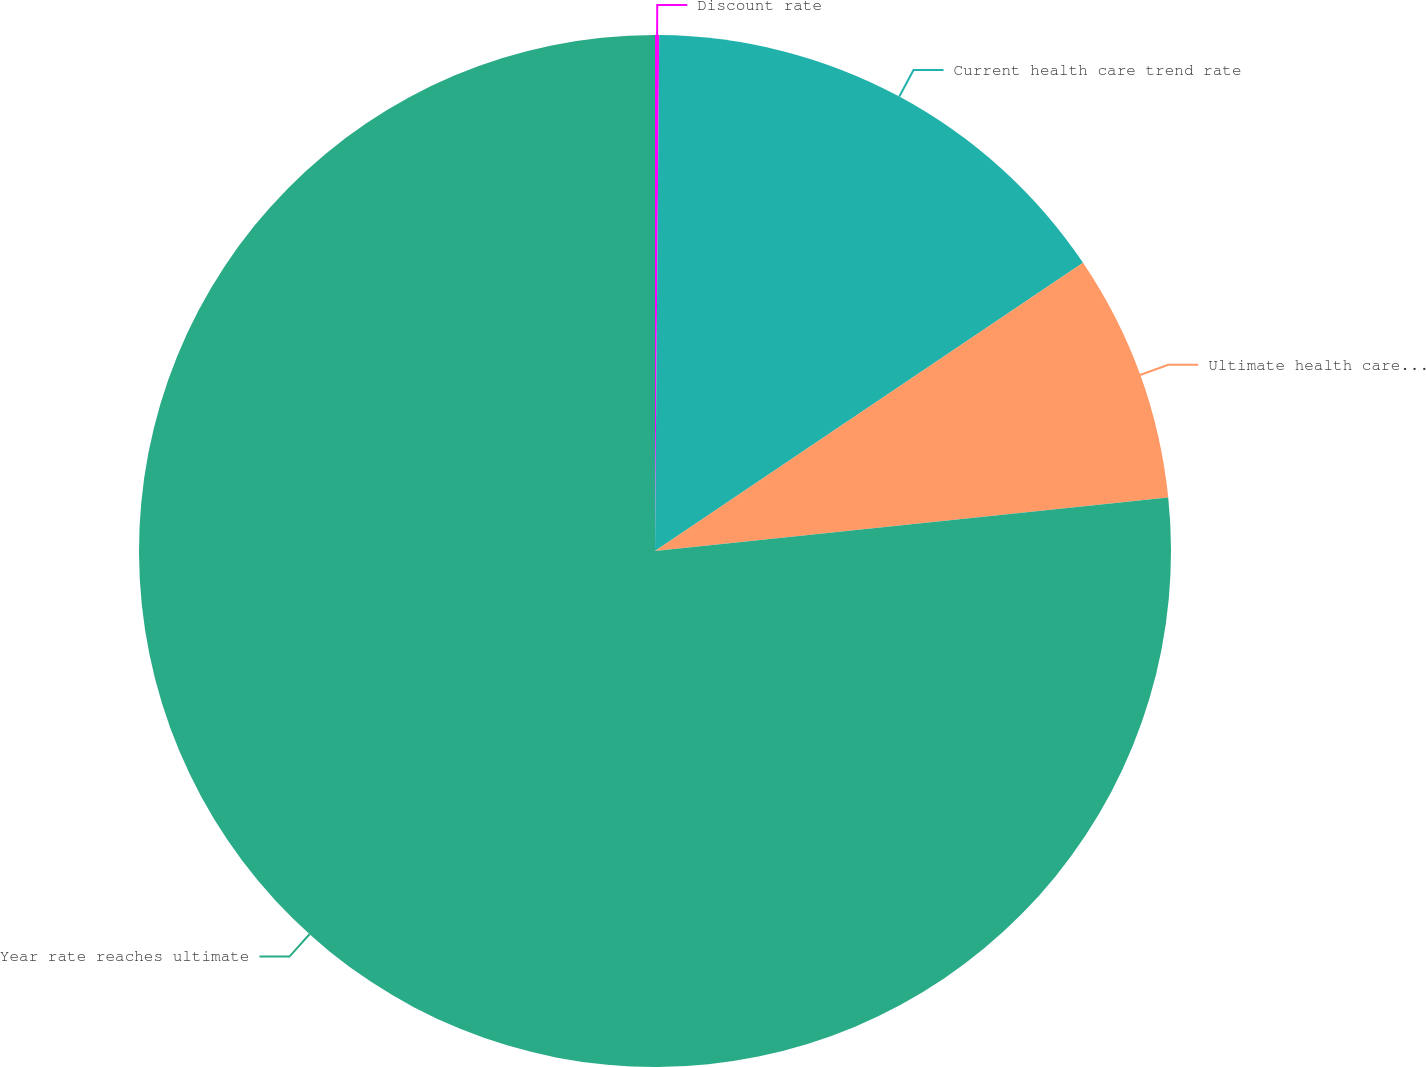<chart> <loc_0><loc_0><loc_500><loc_500><pie_chart><fcel>Discount rate<fcel>Current health care trend rate<fcel>Ultimate health care trend<fcel>Year rate reaches ultimate<nl><fcel>0.13%<fcel>15.44%<fcel>7.78%<fcel>76.65%<nl></chart> 